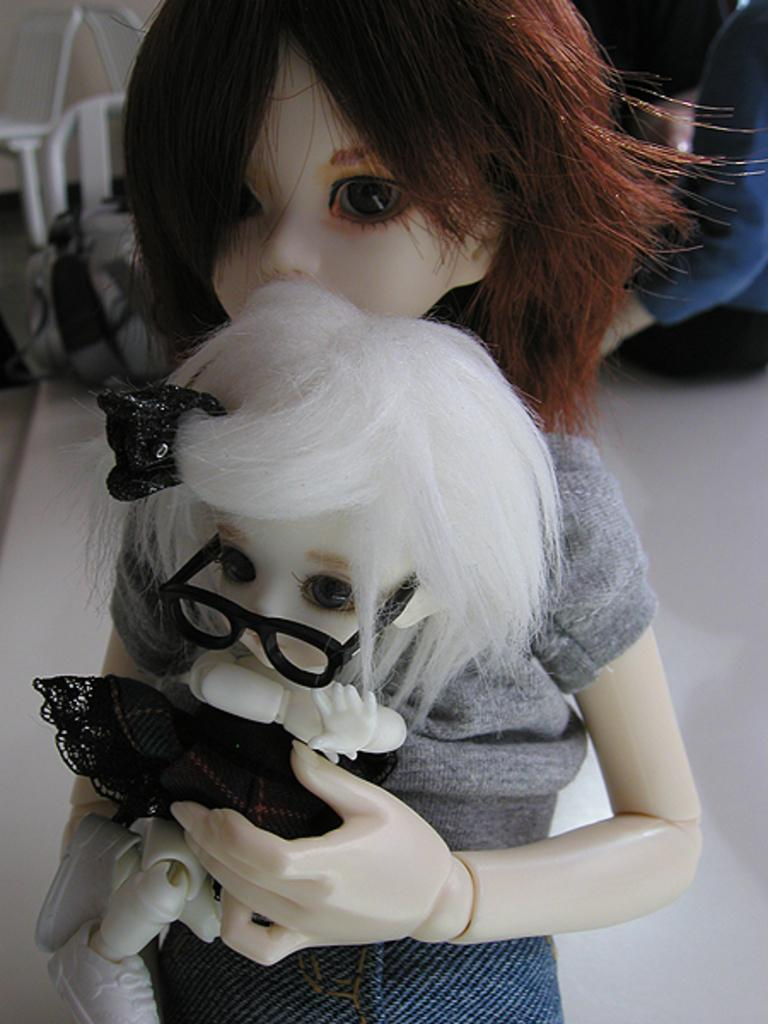What is the main subject of the image? There is a doll holding another doll in the image. What can be observed about the background of the image? The background of the image appears to be white. Can you tell me how many zebras are swimming in the lake in the image? There is no lake or zebras present in the image; it features a doll holding another doll with a white background. 